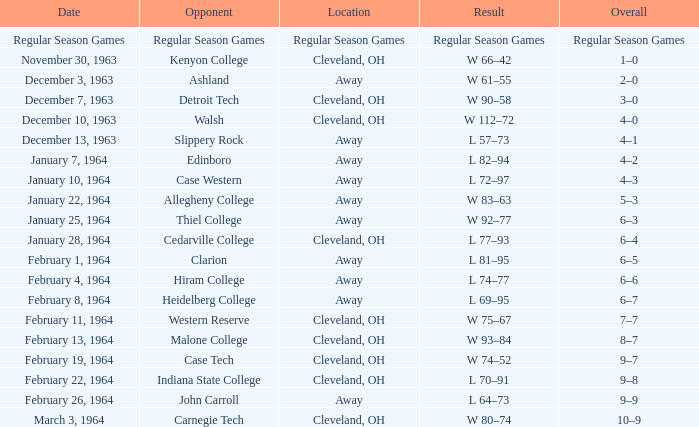What is the Overall with a Date that is february 4, 1964? 6–6. 